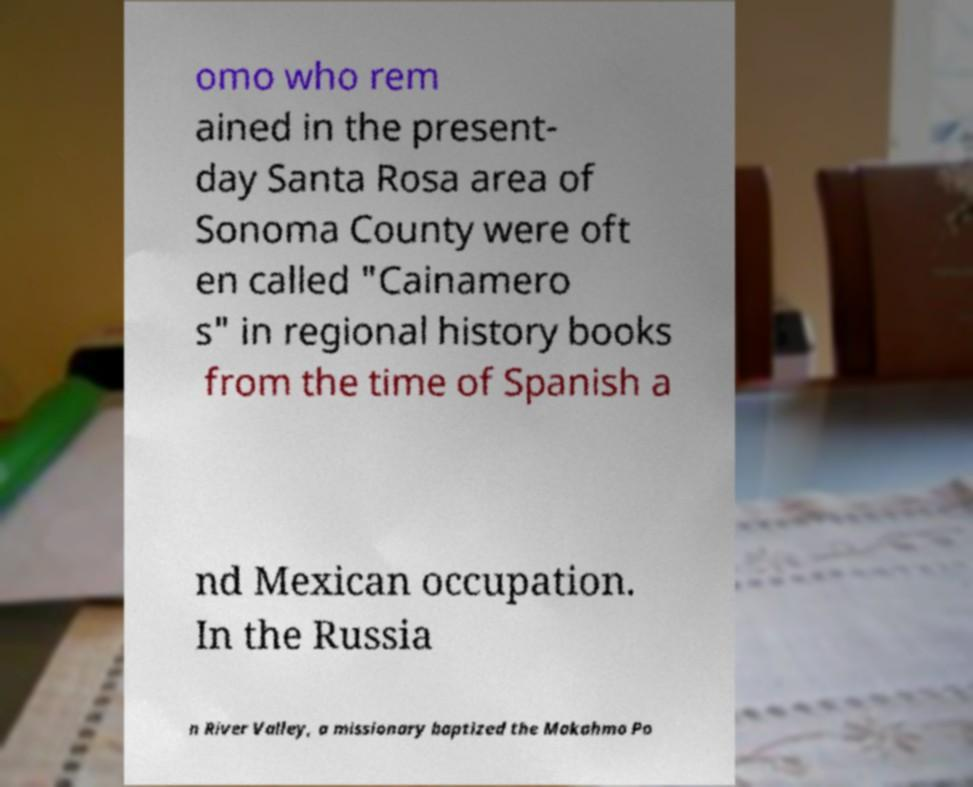For documentation purposes, I need the text within this image transcribed. Could you provide that? omo who rem ained in the present- day Santa Rosa area of Sonoma County were oft en called "Cainamero s" in regional history books from the time of Spanish a nd Mexican occupation. In the Russia n River Valley, a missionary baptized the Makahmo Po 